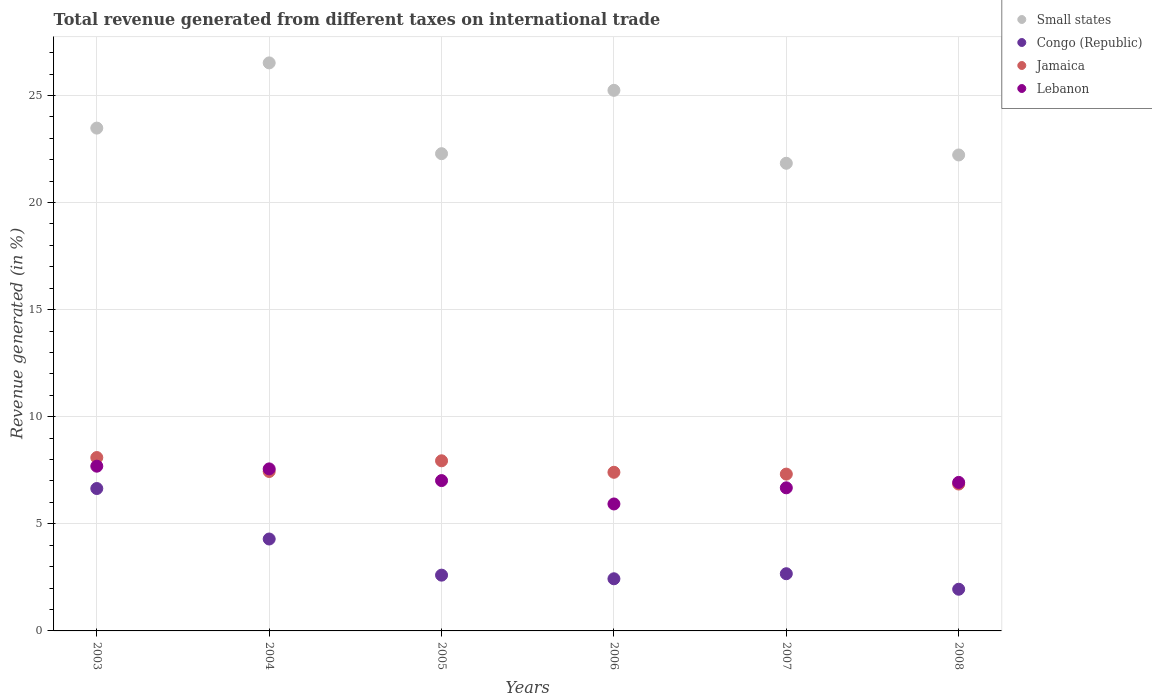Is the number of dotlines equal to the number of legend labels?
Your answer should be compact. Yes. What is the total revenue generated in Lebanon in 2008?
Ensure brevity in your answer.  6.93. Across all years, what is the maximum total revenue generated in Jamaica?
Your response must be concise. 8.1. Across all years, what is the minimum total revenue generated in Lebanon?
Provide a succinct answer. 5.93. What is the total total revenue generated in Small states in the graph?
Offer a very short reply. 141.58. What is the difference between the total revenue generated in Jamaica in 2004 and that in 2008?
Ensure brevity in your answer.  0.59. What is the difference between the total revenue generated in Small states in 2006 and the total revenue generated in Congo (Republic) in 2005?
Your answer should be compact. 22.64. What is the average total revenue generated in Congo (Republic) per year?
Offer a terse response. 3.43. In the year 2007, what is the difference between the total revenue generated in Lebanon and total revenue generated in Congo (Republic)?
Your answer should be compact. 4.01. What is the ratio of the total revenue generated in Congo (Republic) in 2007 to that in 2008?
Ensure brevity in your answer.  1.37. What is the difference between the highest and the second highest total revenue generated in Congo (Republic)?
Your answer should be very brief. 2.36. What is the difference between the highest and the lowest total revenue generated in Congo (Republic)?
Provide a short and direct response. 4.7. Is it the case that in every year, the sum of the total revenue generated in Small states and total revenue generated in Lebanon  is greater than the sum of total revenue generated in Jamaica and total revenue generated in Congo (Republic)?
Your answer should be compact. Yes. Is it the case that in every year, the sum of the total revenue generated in Jamaica and total revenue generated in Congo (Republic)  is greater than the total revenue generated in Lebanon?
Ensure brevity in your answer.  Yes. Does the total revenue generated in Lebanon monotonically increase over the years?
Offer a very short reply. No. Is the total revenue generated in Jamaica strictly less than the total revenue generated in Congo (Republic) over the years?
Give a very brief answer. No. How many dotlines are there?
Provide a succinct answer. 4. How many years are there in the graph?
Provide a short and direct response. 6. What is the difference between two consecutive major ticks on the Y-axis?
Your answer should be very brief. 5. Are the values on the major ticks of Y-axis written in scientific E-notation?
Offer a terse response. No. Where does the legend appear in the graph?
Your answer should be very brief. Top right. What is the title of the graph?
Make the answer very short. Total revenue generated from different taxes on international trade. Does "Trinidad and Tobago" appear as one of the legend labels in the graph?
Your response must be concise. No. What is the label or title of the X-axis?
Offer a very short reply. Years. What is the label or title of the Y-axis?
Offer a very short reply. Revenue generated (in %). What is the Revenue generated (in %) in Small states in 2003?
Provide a short and direct response. 23.48. What is the Revenue generated (in %) of Congo (Republic) in 2003?
Your answer should be very brief. 6.65. What is the Revenue generated (in %) of Jamaica in 2003?
Offer a terse response. 8.1. What is the Revenue generated (in %) of Lebanon in 2003?
Offer a very short reply. 7.69. What is the Revenue generated (in %) of Small states in 2004?
Keep it short and to the point. 26.52. What is the Revenue generated (in %) of Congo (Republic) in 2004?
Offer a very short reply. 4.29. What is the Revenue generated (in %) of Jamaica in 2004?
Give a very brief answer. 7.44. What is the Revenue generated (in %) in Lebanon in 2004?
Keep it short and to the point. 7.57. What is the Revenue generated (in %) in Small states in 2005?
Provide a short and direct response. 22.28. What is the Revenue generated (in %) of Congo (Republic) in 2005?
Give a very brief answer. 2.6. What is the Revenue generated (in %) of Jamaica in 2005?
Offer a very short reply. 7.94. What is the Revenue generated (in %) of Lebanon in 2005?
Your response must be concise. 7.02. What is the Revenue generated (in %) in Small states in 2006?
Provide a short and direct response. 25.24. What is the Revenue generated (in %) in Congo (Republic) in 2006?
Give a very brief answer. 2.43. What is the Revenue generated (in %) in Jamaica in 2006?
Your answer should be very brief. 7.41. What is the Revenue generated (in %) of Lebanon in 2006?
Provide a short and direct response. 5.93. What is the Revenue generated (in %) in Small states in 2007?
Your response must be concise. 21.84. What is the Revenue generated (in %) of Congo (Republic) in 2007?
Make the answer very short. 2.67. What is the Revenue generated (in %) in Jamaica in 2007?
Provide a short and direct response. 7.32. What is the Revenue generated (in %) of Lebanon in 2007?
Provide a short and direct response. 6.68. What is the Revenue generated (in %) of Small states in 2008?
Keep it short and to the point. 22.22. What is the Revenue generated (in %) of Congo (Republic) in 2008?
Your answer should be very brief. 1.95. What is the Revenue generated (in %) of Jamaica in 2008?
Keep it short and to the point. 6.86. What is the Revenue generated (in %) of Lebanon in 2008?
Ensure brevity in your answer.  6.93. Across all years, what is the maximum Revenue generated (in %) in Small states?
Ensure brevity in your answer.  26.52. Across all years, what is the maximum Revenue generated (in %) of Congo (Republic)?
Your response must be concise. 6.65. Across all years, what is the maximum Revenue generated (in %) of Jamaica?
Keep it short and to the point. 8.1. Across all years, what is the maximum Revenue generated (in %) of Lebanon?
Make the answer very short. 7.69. Across all years, what is the minimum Revenue generated (in %) in Small states?
Make the answer very short. 21.84. Across all years, what is the minimum Revenue generated (in %) of Congo (Republic)?
Make the answer very short. 1.95. Across all years, what is the minimum Revenue generated (in %) of Jamaica?
Give a very brief answer. 6.86. Across all years, what is the minimum Revenue generated (in %) in Lebanon?
Offer a terse response. 5.93. What is the total Revenue generated (in %) of Small states in the graph?
Offer a terse response. 141.58. What is the total Revenue generated (in %) in Congo (Republic) in the graph?
Your response must be concise. 20.6. What is the total Revenue generated (in %) of Jamaica in the graph?
Your answer should be very brief. 45.07. What is the total Revenue generated (in %) in Lebanon in the graph?
Offer a terse response. 41.82. What is the difference between the Revenue generated (in %) in Small states in 2003 and that in 2004?
Your answer should be compact. -3.04. What is the difference between the Revenue generated (in %) in Congo (Republic) in 2003 and that in 2004?
Make the answer very short. 2.36. What is the difference between the Revenue generated (in %) of Jamaica in 2003 and that in 2004?
Provide a succinct answer. 0.65. What is the difference between the Revenue generated (in %) of Lebanon in 2003 and that in 2004?
Your answer should be compact. 0.13. What is the difference between the Revenue generated (in %) in Small states in 2003 and that in 2005?
Your response must be concise. 1.19. What is the difference between the Revenue generated (in %) of Congo (Republic) in 2003 and that in 2005?
Your answer should be compact. 4.04. What is the difference between the Revenue generated (in %) in Jamaica in 2003 and that in 2005?
Your response must be concise. 0.15. What is the difference between the Revenue generated (in %) in Lebanon in 2003 and that in 2005?
Ensure brevity in your answer.  0.67. What is the difference between the Revenue generated (in %) of Small states in 2003 and that in 2006?
Your response must be concise. -1.76. What is the difference between the Revenue generated (in %) of Congo (Republic) in 2003 and that in 2006?
Your answer should be compact. 4.21. What is the difference between the Revenue generated (in %) in Jamaica in 2003 and that in 2006?
Your answer should be compact. 0.69. What is the difference between the Revenue generated (in %) in Lebanon in 2003 and that in 2006?
Make the answer very short. 1.76. What is the difference between the Revenue generated (in %) of Small states in 2003 and that in 2007?
Ensure brevity in your answer.  1.64. What is the difference between the Revenue generated (in %) of Congo (Republic) in 2003 and that in 2007?
Offer a very short reply. 3.98. What is the difference between the Revenue generated (in %) in Jamaica in 2003 and that in 2007?
Ensure brevity in your answer.  0.77. What is the difference between the Revenue generated (in %) of Lebanon in 2003 and that in 2007?
Offer a very short reply. 1.01. What is the difference between the Revenue generated (in %) of Small states in 2003 and that in 2008?
Provide a succinct answer. 1.25. What is the difference between the Revenue generated (in %) of Congo (Republic) in 2003 and that in 2008?
Provide a short and direct response. 4.7. What is the difference between the Revenue generated (in %) of Jamaica in 2003 and that in 2008?
Provide a succinct answer. 1.24. What is the difference between the Revenue generated (in %) of Lebanon in 2003 and that in 2008?
Make the answer very short. 0.76. What is the difference between the Revenue generated (in %) in Small states in 2004 and that in 2005?
Give a very brief answer. 4.24. What is the difference between the Revenue generated (in %) of Congo (Republic) in 2004 and that in 2005?
Your answer should be very brief. 1.69. What is the difference between the Revenue generated (in %) of Jamaica in 2004 and that in 2005?
Ensure brevity in your answer.  -0.5. What is the difference between the Revenue generated (in %) of Lebanon in 2004 and that in 2005?
Provide a succinct answer. 0.55. What is the difference between the Revenue generated (in %) in Small states in 2004 and that in 2006?
Offer a very short reply. 1.28. What is the difference between the Revenue generated (in %) in Congo (Republic) in 2004 and that in 2006?
Ensure brevity in your answer.  1.86. What is the difference between the Revenue generated (in %) of Jamaica in 2004 and that in 2006?
Ensure brevity in your answer.  0.04. What is the difference between the Revenue generated (in %) of Lebanon in 2004 and that in 2006?
Make the answer very short. 1.64. What is the difference between the Revenue generated (in %) in Small states in 2004 and that in 2007?
Provide a short and direct response. 4.69. What is the difference between the Revenue generated (in %) in Congo (Republic) in 2004 and that in 2007?
Ensure brevity in your answer.  1.62. What is the difference between the Revenue generated (in %) in Jamaica in 2004 and that in 2007?
Your answer should be compact. 0.12. What is the difference between the Revenue generated (in %) of Lebanon in 2004 and that in 2007?
Make the answer very short. 0.88. What is the difference between the Revenue generated (in %) in Small states in 2004 and that in 2008?
Give a very brief answer. 4.3. What is the difference between the Revenue generated (in %) in Congo (Republic) in 2004 and that in 2008?
Ensure brevity in your answer.  2.35. What is the difference between the Revenue generated (in %) in Jamaica in 2004 and that in 2008?
Give a very brief answer. 0.59. What is the difference between the Revenue generated (in %) of Lebanon in 2004 and that in 2008?
Provide a succinct answer. 0.63. What is the difference between the Revenue generated (in %) in Small states in 2005 and that in 2006?
Your answer should be compact. -2.96. What is the difference between the Revenue generated (in %) of Congo (Republic) in 2005 and that in 2006?
Your answer should be compact. 0.17. What is the difference between the Revenue generated (in %) in Jamaica in 2005 and that in 2006?
Offer a very short reply. 0.54. What is the difference between the Revenue generated (in %) of Lebanon in 2005 and that in 2006?
Make the answer very short. 1.09. What is the difference between the Revenue generated (in %) in Small states in 2005 and that in 2007?
Provide a short and direct response. 0.45. What is the difference between the Revenue generated (in %) of Congo (Republic) in 2005 and that in 2007?
Your response must be concise. -0.07. What is the difference between the Revenue generated (in %) of Jamaica in 2005 and that in 2007?
Offer a terse response. 0.62. What is the difference between the Revenue generated (in %) of Lebanon in 2005 and that in 2007?
Your answer should be compact. 0.34. What is the difference between the Revenue generated (in %) in Small states in 2005 and that in 2008?
Provide a short and direct response. 0.06. What is the difference between the Revenue generated (in %) in Congo (Republic) in 2005 and that in 2008?
Provide a succinct answer. 0.66. What is the difference between the Revenue generated (in %) of Jamaica in 2005 and that in 2008?
Provide a short and direct response. 1.09. What is the difference between the Revenue generated (in %) in Lebanon in 2005 and that in 2008?
Make the answer very short. 0.08. What is the difference between the Revenue generated (in %) in Small states in 2006 and that in 2007?
Provide a succinct answer. 3.41. What is the difference between the Revenue generated (in %) of Congo (Republic) in 2006 and that in 2007?
Make the answer very short. -0.24. What is the difference between the Revenue generated (in %) of Jamaica in 2006 and that in 2007?
Give a very brief answer. 0.08. What is the difference between the Revenue generated (in %) of Lebanon in 2006 and that in 2007?
Provide a succinct answer. -0.75. What is the difference between the Revenue generated (in %) of Small states in 2006 and that in 2008?
Your answer should be very brief. 3.02. What is the difference between the Revenue generated (in %) of Congo (Republic) in 2006 and that in 2008?
Give a very brief answer. 0.49. What is the difference between the Revenue generated (in %) in Jamaica in 2006 and that in 2008?
Your answer should be very brief. 0.55. What is the difference between the Revenue generated (in %) of Lebanon in 2006 and that in 2008?
Offer a terse response. -1.01. What is the difference between the Revenue generated (in %) of Small states in 2007 and that in 2008?
Your response must be concise. -0.39. What is the difference between the Revenue generated (in %) in Congo (Republic) in 2007 and that in 2008?
Your response must be concise. 0.72. What is the difference between the Revenue generated (in %) of Jamaica in 2007 and that in 2008?
Your answer should be compact. 0.46. What is the difference between the Revenue generated (in %) in Lebanon in 2007 and that in 2008?
Your answer should be compact. -0.25. What is the difference between the Revenue generated (in %) of Small states in 2003 and the Revenue generated (in %) of Congo (Republic) in 2004?
Your answer should be compact. 19.19. What is the difference between the Revenue generated (in %) of Small states in 2003 and the Revenue generated (in %) of Jamaica in 2004?
Offer a very short reply. 16.03. What is the difference between the Revenue generated (in %) of Small states in 2003 and the Revenue generated (in %) of Lebanon in 2004?
Your answer should be compact. 15.91. What is the difference between the Revenue generated (in %) of Congo (Republic) in 2003 and the Revenue generated (in %) of Jamaica in 2004?
Keep it short and to the point. -0.8. What is the difference between the Revenue generated (in %) of Congo (Republic) in 2003 and the Revenue generated (in %) of Lebanon in 2004?
Make the answer very short. -0.92. What is the difference between the Revenue generated (in %) in Jamaica in 2003 and the Revenue generated (in %) in Lebanon in 2004?
Provide a succinct answer. 0.53. What is the difference between the Revenue generated (in %) in Small states in 2003 and the Revenue generated (in %) in Congo (Republic) in 2005?
Offer a very short reply. 20.87. What is the difference between the Revenue generated (in %) of Small states in 2003 and the Revenue generated (in %) of Jamaica in 2005?
Your response must be concise. 15.53. What is the difference between the Revenue generated (in %) of Small states in 2003 and the Revenue generated (in %) of Lebanon in 2005?
Provide a short and direct response. 16.46. What is the difference between the Revenue generated (in %) of Congo (Republic) in 2003 and the Revenue generated (in %) of Jamaica in 2005?
Give a very brief answer. -1.29. What is the difference between the Revenue generated (in %) of Congo (Republic) in 2003 and the Revenue generated (in %) of Lebanon in 2005?
Your answer should be very brief. -0.37. What is the difference between the Revenue generated (in %) in Jamaica in 2003 and the Revenue generated (in %) in Lebanon in 2005?
Make the answer very short. 1.08. What is the difference between the Revenue generated (in %) of Small states in 2003 and the Revenue generated (in %) of Congo (Republic) in 2006?
Your response must be concise. 21.04. What is the difference between the Revenue generated (in %) in Small states in 2003 and the Revenue generated (in %) in Jamaica in 2006?
Your answer should be compact. 16.07. What is the difference between the Revenue generated (in %) of Small states in 2003 and the Revenue generated (in %) of Lebanon in 2006?
Your answer should be very brief. 17.55. What is the difference between the Revenue generated (in %) in Congo (Republic) in 2003 and the Revenue generated (in %) in Jamaica in 2006?
Offer a very short reply. -0.76. What is the difference between the Revenue generated (in %) in Congo (Republic) in 2003 and the Revenue generated (in %) in Lebanon in 2006?
Provide a succinct answer. 0.72. What is the difference between the Revenue generated (in %) of Jamaica in 2003 and the Revenue generated (in %) of Lebanon in 2006?
Provide a succinct answer. 2.17. What is the difference between the Revenue generated (in %) in Small states in 2003 and the Revenue generated (in %) in Congo (Republic) in 2007?
Your answer should be compact. 20.81. What is the difference between the Revenue generated (in %) of Small states in 2003 and the Revenue generated (in %) of Jamaica in 2007?
Your response must be concise. 16.15. What is the difference between the Revenue generated (in %) of Small states in 2003 and the Revenue generated (in %) of Lebanon in 2007?
Offer a terse response. 16.8. What is the difference between the Revenue generated (in %) of Congo (Republic) in 2003 and the Revenue generated (in %) of Jamaica in 2007?
Provide a succinct answer. -0.67. What is the difference between the Revenue generated (in %) of Congo (Republic) in 2003 and the Revenue generated (in %) of Lebanon in 2007?
Keep it short and to the point. -0.03. What is the difference between the Revenue generated (in %) in Jamaica in 2003 and the Revenue generated (in %) in Lebanon in 2007?
Give a very brief answer. 1.41. What is the difference between the Revenue generated (in %) in Small states in 2003 and the Revenue generated (in %) in Congo (Republic) in 2008?
Provide a short and direct response. 21.53. What is the difference between the Revenue generated (in %) of Small states in 2003 and the Revenue generated (in %) of Jamaica in 2008?
Provide a short and direct response. 16.62. What is the difference between the Revenue generated (in %) of Small states in 2003 and the Revenue generated (in %) of Lebanon in 2008?
Offer a terse response. 16.54. What is the difference between the Revenue generated (in %) of Congo (Republic) in 2003 and the Revenue generated (in %) of Jamaica in 2008?
Make the answer very short. -0.21. What is the difference between the Revenue generated (in %) of Congo (Republic) in 2003 and the Revenue generated (in %) of Lebanon in 2008?
Offer a terse response. -0.29. What is the difference between the Revenue generated (in %) in Jamaica in 2003 and the Revenue generated (in %) in Lebanon in 2008?
Provide a short and direct response. 1.16. What is the difference between the Revenue generated (in %) of Small states in 2004 and the Revenue generated (in %) of Congo (Republic) in 2005?
Your answer should be compact. 23.92. What is the difference between the Revenue generated (in %) of Small states in 2004 and the Revenue generated (in %) of Jamaica in 2005?
Offer a very short reply. 18.58. What is the difference between the Revenue generated (in %) of Small states in 2004 and the Revenue generated (in %) of Lebanon in 2005?
Provide a succinct answer. 19.5. What is the difference between the Revenue generated (in %) of Congo (Republic) in 2004 and the Revenue generated (in %) of Jamaica in 2005?
Provide a succinct answer. -3.65. What is the difference between the Revenue generated (in %) in Congo (Republic) in 2004 and the Revenue generated (in %) in Lebanon in 2005?
Make the answer very short. -2.73. What is the difference between the Revenue generated (in %) in Jamaica in 2004 and the Revenue generated (in %) in Lebanon in 2005?
Provide a succinct answer. 0.42. What is the difference between the Revenue generated (in %) of Small states in 2004 and the Revenue generated (in %) of Congo (Republic) in 2006?
Make the answer very short. 24.09. What is the difference between the Revenue generated (in %) of Small states in 2004 and the Revenue generated (in %) of Jamaica in 2006?
Ensure brevity in your answer.  19.11. What is the difference between the Revenue generated (in %) in Small states in 2004 and the Revenue generated (in %) in Lebanon in 2006?
Give a very brief answer. 20.59. What is the difference between the Revenue generated (in %) of Congo (Republic) in 2004 and the Revenue generated (in %) of Jamaica in 2006?
Ensure brevity in your answer.  -3.12. What is the difference between the Revenue generated (in %) of Congo (Republic) in 2004 and the Revenue generated (in %) of Lebanon in 2006?
Ensure brevity in your answer.  -1.64. What is the difference between the Revenue generated (in %) in Jamaica in 2004 and the Revenue generated (in %) in Lebanon in 2006?
Offer a very short reply. 1.52. What is the difference between the Revenue generated (in %) in Small states in 2004 and the Revenue generated (in %) in Congo (Republic) in 2007?
Make the answer very short. 23.85. What is the difference between the Revenue generated (in %) of Small states in 2004 and the Revenue generated (in %) of Jamaica in 2007?
Make the answer very short. 19.2. What is the difference between the Revenue generated (in %) in Small states in 2004 and the Revenue generated (in %) in Lebanon in 2007?
Your answer should be compact. 19.84. What is the difference between the Revenue generated (in %) in Congo (Republic) in 2004 and the Revenue generated (in %) in Jamaica in 2007?
Give a very brief answer. -3.03. What is the difference between the Revenue generated (in %) in Congo (Republic) in 2004 and the Revenue generated (in %) in Lebanon in 2007?
Your answer should be very brief. -2.39. What is the difference between the Revenue generated (in %) of Jamaica in 2004 and the Revenue generated (in %) of Lebanon in 2007?
Make the answer very short. 0.76. What is the difference between the Revenue generated (in %) of Small states in 2004 and the Revenue generated (in %) of Congo (Republic) in 2008?
Offer a very short reply. 24.58. What is the difference between the Revenue generated (in %) in Small states in 2004 and the Revenue generated (in %) in Jamaica in 2008?
Your answer should be very brief. 19.66. What is the difference between the Revenue generated (in %) of Small states in 2004 and the Revenue generated (in %) of Lebanon in 2008?
Provide a short and direct response. 19.59. What is the difference between the Revenue generated (in %) of Congo (Republic) in 2004 and the Revenue generated (in %) of Jamaica in 2008?
Provide a succinct answer. -2.57. What is the difference between the Revenue generated (in %) in Congo (Republic) in 2004 and the Revenue generated (in %) in Lebanon in 2008?
Your response must be concise. -2.64. What is the difference between the Revenue generated (in %) of Jamaica in 2004 and the Revenue generated (in %) of Lebanon in 2008?
Make the answer very short. 0.51. What is the difference between the Revenue generated (in %) in Small states in 2005 and the Revenue generated (in %) in Congo (Republic) in 2006?
Your response must be concise. 19.85. What is the difference between the Revenue generated (in %) of Small states in 2005 and the Revenue generated (in %) of Jamaica in 2006?
Your answer should be very brief. 14.88. What is the difference between the Revenue generated (in %) in Small states in 2005 and the Revenue generated (in %) in Lebanon in 2006?
Provide a short and direct response. 16.35. What is the difference between the Revenue generated (in %) in Congo (Republic) in 2005 and the Revenue generated (in %) in Jamaica in 2006?
Your answer should be compact. -4.8. What is the difference between the Revenue generated (in %) of Congo (Republic) in 2005 and the Revenue generated (in %) of Lebanon in 2006?
Provide a short and direct response. -3.32. What is the difference between the Revenue generated (in %) in Jamaica in 2005 and the Revenue generated (in %) in Lebanon in 2006?
Keep it short and to the point. 2.02. What is the difference between the Revenue generated (in %) in Small states in 2005 and the Revenue generated (in %) in Congo (Republic) in 2007?
Your answer should be compact. 19.61. What is the difference between the Revenue generated (in %) of Small states in 2005 and the Revenue generated (in %) of Jamaica in 2007?
Ensure brevity in your answer.  14.96. What is the difference between the Revenue generated (in %) of Small states in 2005 and the Revenue generated (in %) of Lebanon in 2007?
Offer a terse response. 15.6. What is the difference between the Revenue generated (in %) of Congo (Republic) in 2005 and the Revenue generated (in %) of Jamaica in 2007?
Keep it short and to the point. -4.72. What is the difference between the Revenue generated (in %) in Congo (Republic) in 2005 and the Revenue generated (in %) in Lebanon in 2007?
Provide a short and direct response. -4.08. What is the difference between the Revenue generated (in %) of Jamaica in 2005 and the Revenue generated (in %) of Lebanon in 2007?
Provide a short and direct response. 1.26. What is the difference between the Revenue generated (in %) in Small states in 2005 and the Revenue generated (in %) in Congo (Republic) in 2008?
Ensure brevity in your answer.  20.34. What is the difference between the Revenue generated (in %) in Small states in 2005 and the Revenue generated (in %) in Jamaica in 2008?
Keep it short and to the point. 15.42. What is the difference between the Revenue generated (in %) of Small states in 2005 and the Revenue generated (in %) of Lebanon in 2008?
Your response must be concise. 15.35. What is the difference between the Revenue generated (in %) in Congo (Republic) in 2005 and the Revenue generated (in %) in Jamaica in 2008?
Offer a very short reply. -4.25. What is the difference between the Revenue generated (in %) in Congo (Republic) in 2005 and the Revenue generated (in %) in Lebanon in 2008?
Your response must be concise. -4.33. What is the difference between the Revenue generated (in %) in Jamaica in 2005 and the Revenue generated (in %) in Lebanon in 2008?
Keep it short and to the point. 1.01. What is the difference between the Revenue generated (in %) of Small states in 2006 and the Revenue generated (in %) of Congo (Republic) in 2007?
Give a very brief answer. 22.57. What is the difference between the Revenue generated (in %) of Small states in 2006 and the Revenue generated (in %) of Jamaica in 2007?
Provide a succinct answer. 17.92. What is the difference between the Revenue generated (in %) in Small states in 2006 and the Revenue generated (in %) in Lebanon in 2007?
Your response must be concise. 18.56. What is the difference between the Revenue generated (in %) of Congo (Republic) in 2006 and the Revenue generated (in %) of Jamaica in 2007?
Keep it short and to the point. -4.89. What is the difference between the Revenue generated (in %) in Congo (Republic) in 2006 and the Revenue generated (in %) in Lebanon in 2007?
Provide a short and direct response. -4.25. What is the difference between the Revenue generated (in %) in Jamaica in 2006 and the Revenue generated (in %) in Lebanon in 2007?
Offer a terse response. 0.73. What is the difference between the Revenue generated (in %) of Small states in 2006 and the Revenue generated (in %) of Congo (Republic) in 2008?
Your response must be concise. 23.29. What is the difference between the Revenue generated (in %) of Small states in 2006 and the Revenue generated (in %) of Jamaica in 2008?
Keep it short and to the point. 18.38. What is the difference between the Revenue generated (in %) of Small states in 2006 and the Revenue generated (in %) of Lebanon in 2008?
Your answer should be compact. 18.31. What is the difference between the Revenue generated (in %) of Congo (Republic) in 2006 and the Revenue generated (in %) of Jamaica in 2008?
Make the answer very short. -4.42. What is the difference between the Revenue generated (in %) of Congo (Republic) in 2006 and the Revenue generated (in %) of Lebanon in 2008?
Your answer should be compact. -4.5. What is the difference between the Revenue generated (in %) of Jamaica in 2006 and the Revenue generated (in %) of Lebanon in 2008?
Keep it short and to the point. 0.47. What is the difference between the Revenue generated (in %) in Small states in 2007 and the Revenue generated (in %) in Congo (Republic) in 2008?
Offer a terse response. 19.89. What is the difference between the Revenue generated (in %) of Small states in 2007 and the Revenue generated (in %) of Jamaica in 2008?
Give a very brief answer. 14.98. What is the difference between the Revenue generated (in %) of Small states in 2007 and the Revenue generated (in %) of Lebanon in 2008?
Your response must be concise. 14.9. What is the difference between the Revenue generated (in %) of Congo (Republic) in 2007 and the Revenue generated (in %) of Jamaica in 2008?
Your response must be concise. -4.19. What is the difference between the Revenue generated (in %) of Congo (Republic) in 2007 and the Revenue generated (in %) of Lebanon in 2008?
Your response must be concise. -4.26. What is the difference between the Revenue generated (in %) in Jamaica in 2007 and the Revenue generated (in %) in Lebanon in 2008?
Provide a short and direct response. 0.39. What is the average Revenue generated (in %) of Small states per year?
Offer a terse response. 23.6. What is the average Revenue generated (in %) of Congo (Republic) per year?
Make the answer very short. 3.43. What is the average Revenue generated (in %) in Jamaica per year?
Offer a very short reply. 7.51. What is the average Revenue generated (in %) of Lebanon per year?
Ensure brevity in your answer.  6.97. In the year 2003, what is the difference between the Revenue generated (in %) of Small states and Revenue generated (in %) of Congo (Republic)?
Make the answer very short. 16.83. In the year 2003, what is the difference between the Revenue generated (in %) of Small states and Revenue generated (in %) of Jamaica?
Offer a terse response. 15.38. In the year 2003, what is the difference between the Revenue generated (in %) in Small states and Revenue generated (in %) in Lebanon?
Offer a very short reply. 15.79. In the year 2003, what is the difference between the Revenue generated (in %) in Congo (Republic) and Revenue generated (in %) in Jamaica?
Keep it short and to the point. -1.45. In the year 2003, what is the difference between the Revenue generated (in %) in Congo (Republic) and Revenue generated (in %) in Lebanon?
Offer a very short reply. -1.04. In the year 2003, what is the difference between the Revenue generated (in %) in Jamaica and Revenue generated (in %) in Lebanon?
Your answer should be very brief. 0.4. In the year 2004, what is the difference between the Revenue generated (in %) in Small states and Revenue generated (in %) in Congo (Republic)?
Ensure brevity in your answer.  22.23. In the year 2004, what is the difference between the Revenue generated (in %) in Small states and Revenue generated (in %) in Jamaica?
Your response must be concise. 19.08. In the year 2004, what is the difference between the Revenue generated (in %) in Small states and Revenue generated (in %) in Lebanon?
Provide a short and direct response. 18.96. In the year 2004, what is the difference between the Revenue generated (in %) in Congo (Republic) and Revenue generated (in %) in Jamaica?
Your response must be concise. -3.15. In the year 2004, what is the difference between the Revenue generated (in %) in Congo (Republic) and Revenue generated (in %) in Lebanon?
Provide a succinct answer. -3.27. In the year 2004, what is the difference between the Revenue generated (in %) of Jamaica and Revenue generated (in %) of Lebanon?
Offer a very short reply. -0.12. In the year 2005, what is the difference between the Revenue generated (in %) of Small states and Revenue generated (in %) of Congo (Republic)?
Make the answer very short. 19.68. In the year 2005, what is the difference between the Revenue generated (in %) in Small states and Revenue generated (in %) in Jamaica?
Your answer should be very brief. 14.34. In the year 2005, what is the difference between the Revenue generated (in %) of Small states and Revenue generated (in %) of Lebanon?
Provide a succinct answer. 15.26. In the year 2005, what is the difference between the Revenue generated (in %) of Congo (Republic) and Revenue generated (in %) of Jamaica?
Your response must be concise. -5.34. In the year 2005, what is the difference between the Revenue generated (in %) in Congo (Republic) and Revenue generated (in %) in Lebanon?
Your response must be concise. -4.42. In the year 2005, what is the difference between the Revenue generated (in %) in Jamaica and Revenue generated (in %) in Lebanon?
Your answer should be very brief. 0.92. In the year 2006, what is the difference between the Revenue generated (in %) of Small states and Revenue generated (in %) of Congo (Republic)?
Keep it short and to the point. 22.81. In the year 2006, what is the difference between the Revenue generated (in %) in Small states and Revenue generated (in %) in Jamaica?
Offer a terse response. 17.83. In the year 2006, what is the difference between the Revenue generated (in %) in Small states and Revenue generated (in %) in Lebanon?
Provide a short and direct response. 19.31. In the year 2006, what is the difference between the Revenue generated (in %) in Congo (Republic) and Revenue generated (in %) in Jamaica?
Provide a succinct answer. -4.97. In the year 2006, what is the difference between the Revenue generated (in %) of Congo (Republic) and Revenue generated (in %) of Lebanon?
Provide a succinct answer. -3.49. In the year 2006, what is the difference between the Revenue generated (in %) in Jamaica and Revenue generated (in %) in Lebanon?
Ensure brevity in your answer.  1.48. In the year 2007, what is the difference between the Revenue generated (in %) of Small states and Revenue generated (in %) of Congo (Republic)?
Give a very brief answer. 19.16. In the year 2007, what is the difference between the Revenue generated (in %) in Small states and Revenue generated (in %) in Jamaica?
Make the answer very short. 14.51. In the year 2007, what is the difference between the Revenue generated (in %) in Small states and Revenue generated (in %) in Lebanon?
Offer a terse response. 15.15. In the year 2007, what is the difference between the Revenue generated (in %) in Congo (Republic) and Revenue generated (in %) in Jamaica?
Your answer should be very brief. -4.65. In the year 2007, what is the difference between the Revenue generated (in %) of Congo (Republic) and Revenue generated (in %) of Lebanon?
Give a very brief answer. -4.01. In the year 2007, what is the difference between the Revenue generated (in %) of Jamaica and Revenue generated (in %) of Lebanon?
Keep it short and to the point. 0.64. In the year 2008, what is the difference between the Revenue generated (in %) of Small states and Revenue generated (in %) of Congo (Republic)?
Ensure brevity in your answer.  20.28. In the year 2008, what is the difference between the Revenue generated (in %) in Small states and Revenue generated (in %) in Jamaica?
Provide a short and direct response. 15.36. In the year 2008, what is the difference between the Revenue generated (in %) of Small states and Revenue generated (in %) of Lebanon?
Give a very brief answer. 15.29. In the year 2008, what is the difference between the Revenue generated (in %) in Congo (Republic) and Revenue generated (in %) in Jamaica?
Provide a short and direct response. -4.91. In the year 2008, what is the difference between the Revenue generated (in %) in Congo (Republic) and Revenue generated (in %) in Lebanon?
Ensure brevity in your answer.  -4.99. In the year 2008, what is the difference between the Revenue generated (in %) of Jamaica and Revenue generated (in %) of Lebanon?
Your answer should be very brief. -0.08. What is the ratio of the Revenue generated (in %) in Small states in 2003 to that in 2004?
Keep it short and to the point. 0.89. What is the ratio of the Revenue generated (in %) in Congo (Republic) in 2003 to that in 2004?
Your response must be concise. 1.55. What is the ratio of the Revenue generated (in %) in Jamaica in 2003 to that in 2004?
Provide a succinct answer. 1.09. What is the ratio of the Revenue generated (in %) in Lebanon in 2003 to that in 2004?
Give a very brief answer. 1.02. What is the ratio of the Revenue generated (in %) of Small states in 2003 to that in 2005?
Your response must be concise. 1.05. What is the ratio of the Revenue generated (in %) of Congo (Republic) in 2003 to that in 2005?
Keep it short and to the point. 2.55. What is the ratio of the Revenue generated (in %) in Jamaica in 2003 to that in 2005?
Ensure brevity in your answer.  1.02. What is the ratio of the Revenue generated (in %) of Lebanon in 2003 to that in 2005?
Your response must be concise. 1.1. What is the ratio of the Revenue generated (in %) of Small states in 2003 to that in 2006?
Your answer should be very brief. 0.93. What is the ratio of the Revenue generated (in %) in Congo (Republic) in 2003 to that in 2006?
Provide a succinct answer. 2.73. What is the ratio of the Revenue generated (in %) in Jamaica in 2003 to that in 2006?
Make the answer very short. 1.09. What is the ratio of the Revenue generated (in %) in Lebanon in 2003 to that in 2006?
Provide a short and direct response. 1.3. What is the ratio of the Revenue generated (in %) of Small states in 2003 to that in 2007?
Make the answer very short. 1.08. What is the ratio of the Revenue generated (in %) of Congo (Republic) in 2003 to that in 2007?
Offer a very short reply. 2.49. What is the ratio of the Revenue generated (in %) in Jamaica in 2003 to that in 2007?
Provide a short and direct response. 1.11. What is the ratio of the Revenue generated (in %) of Lebanon in 2003 to that in 2007?
Give a very brief answer. 1.15. What is the ratio of the Revenue generated (in %) of Small states in 2003 to that in 2008?
Ensure brevity in your answer.  1.06. What is the ratio of the Revenue generated (in %) in Congo (Republic) in 2003 to that in 2008?
Your response must be concise. 3.42. What is the ratio of the Revenue generated (in %) in Jamaica in 2003 to that in 2008?
Make the answer very short. 1.18. What is the ratio of the Revenue generated (in %) of Lebanon in 2003 to that in 2008?
Provide a short and direct response. 1.11. What is the ratio of the Revenue generated (in %) in Small states in 2004 to that in 2005?
Your answer should be very brief. 1.19. What is the ratio of the Revenue generated (in %) of Congo (Republic) in 2004 to that in 2005?
Your response must be concise. 1.65. What is the ratio of the Revenue generated (in %) in Jamaica in 2004 to that in 2005?
Your answer should be very brief. 0.94. What is the ratio of the Revenue generated (in %) in Lebanon in 2004 to that in 2005?
Offer a very short reply. 1.08. What is the ratio of the Revenue generated (in %) of Small states in 2004 to that in 2006?
Make the answer very short. 1.05. What is the ratio of the Revenue generated (in %) in Congo (Republic) in 2004 to that in 2006?
Offer a terse response. 1.76. What is the ratio of the Revenue generated (in %) of Jamaica in 2004 to that in 2006?
Ensure brevity in your answer.  1. What is the ratio of the Revenue generated (in %) in Lebanon in 2004 to that in 2006?
Your answer should be very brief. 1.28. What is the ratio of the Revenue generated (in %) of Small states in 2004 to that in 2007?
Give a very brief answer. 1.21. What is the ratio of the Revenue generated (in %) in Congo (Republic) in 2004 to that in 2007?
Provide a succinct answer. 1.61. What is the ratio of the Revenue generated (in %) in Jamaica in 2004 to that in 2007?
Ensure brevity in your answer.  1.02. What is the ratio of the Revenue generated (in %) in Lebanon in 2004 to that in 2007?
Your response must be concise. 1.13. What is the ratio of the Revenue generated (in %) of Small states in 2004 to that in 2008?
Keep it short and to the point. 1.19. What is the ratio of the Revenue generated (in %) of Congo (Republic) in 2004 to that in 2008?
Your response must be concise. 2.21. What is the ratio of the Revenue generated (in %) of Jamaica in 2004 to that in 2008?
Make the answer very short. 1.09. What is the ratio of the Revenue generated (in %) of Small states in 2005 to that in 2006?
Your answer should be compact. 0.88. What is the ratio of the Revenue generated (in %) of Congo (Republic) in 2005 to that in 2006?
Your answer should be very brief. 1.07. What is the ratio of the Revenue generated (in %) in Jamaica in 2005 to that in 2006?
Offer a very short reply. 1.07. What is the ratio of the Revenue generated (in %) of Lebanon in 2005 to that in 2006?
Make the answer very short. 1.18. What is the ratio of the Revenue generated (in %) of Small states in 2005 to that in 2007?
Provide a succinct answer. 1.02. What is the ratio of the Revenue generated (in %) of Jamaica in 2005 to that in 2007?
Offer a very short reply. 1.08. What is the ratio of the Revenue generated (in %) in Lebanon in 2005 to that in 2007?
Keep it short and to the point. 1.05. What is the ratio of the Revenue generated (in %) of Congo (Republic) in 2005 to that in 2008?
Make the answer very short. 1.34. What is the ratio of the Revenue generated (in %) in Jamaica in 2005 to that in 2008?
Your answer should be very brief. 1.16. What is the ratio of the Revenue generated (in %) in Lebanon in 2005 to that in 2008?
Make the answer very short. 1.01. What is the ratio of the Revenue generated (in %) of Small states in 2006 to that in 2007?
Your answer should be very brief. 1.16. What is the ratio of the Revenue generated (in %) of Congo (Republic) in 2006 to that in 2007?
Offer a terse response. 0.91. What is the ratio of the Revenue generated (in %) in Jamaica in 2006 to that in 2007?
Provide a short and direct response. 1.01. What is the ratio of the Revenue generated (in %) in Lebanon in 2006 to that in 2007?
Make the answer very short. 0.89. What is the ratio of the Revenue generated (in %) in Small states in 2006 to that in 2008?
Make the answer very short. 1.14. What is the ratio of the Revenue generated (in %) of Congo (Republic) in 2006 to that in 2008?
Provide a short and direct response. 1.25. What is the ratio of the Revenue generated (in %) in Lebanon in 2006 to that in 2008?
Your response must be concise. 0.85. What is the ratio of the Revenue generated (in %) of Small states in 2007 to that in 2008?
Offer a terse response. 0.98. What is the ratio of the Revenue generated (in %) of Congo (Republic) in 2007 to that in 2008?
Offer a terse response. 1.37. What is the ratio of the Revenue generated (in %) in Jamaica in 2007 to that in 2008?
Your answer should be very brief. 1.07. What is the ratio of the Revenue generated (in %) in Lebanon in 2007 to that in 2008?
Your answer should be very brief. 0.96. What is the difference between the highest and the second highest Revenue generated (in %) in Small states?
Provide a succinct answer. 1.28. What is the difference between the highest and the second highest Revenue generated (in %) in Congo (Republic)?
Give a very brief answer. 2.36. What is the difference between the highest and the second highest Revenue generated (in %) in Jamaica?
Your response must be concise. 0.15. What is the difference between the highest and the second highest Revenue generated (in %) in Lebanon?
Provide a succinct answer. 0.13. What is the difference between the highest and the lowest Revenue generated (in %) of Small states?
Make the answer very short. 4.69. What is the difference between the highest and the lowest Revenue generated (in %) in Congo (Republic)?
Offer a terse response. 4.7. What is the difference between the highest and the lowest Revenue generated (in %) in Jamaica?
Offer a very short reply. 1.24. What is the difference between the highest and the lowest Revenue generated (in %) of Lebanon?
Offer a terse response. 1.76. 